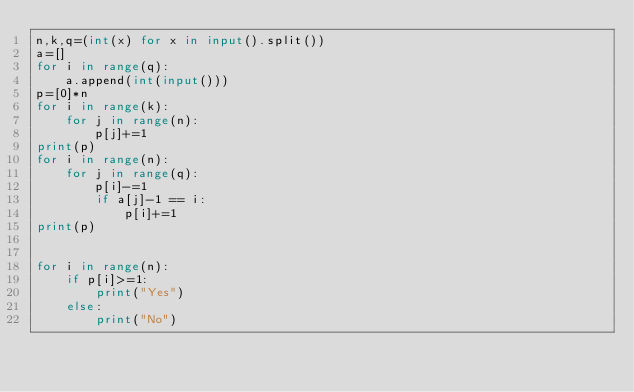<code> <loc_0><loc_0><loc_500><loc_500><_Python_>n,k,q=(int(x) for x in input().split())
a=[]
for i in range(q):
    a.append(int(input()))
p=[0]*n
for i in range(k):
    for j in range(n):
        p[j]+=1
print(p)
for i in range(n):
    for j in range(q):
        p[i]-=1
        if a[j]-1 == i:
            p[i]+=1
print(p)


for i in range(n):
    if p[i]>=1:
        print("Yes")
    else:
        print("No")</code> 